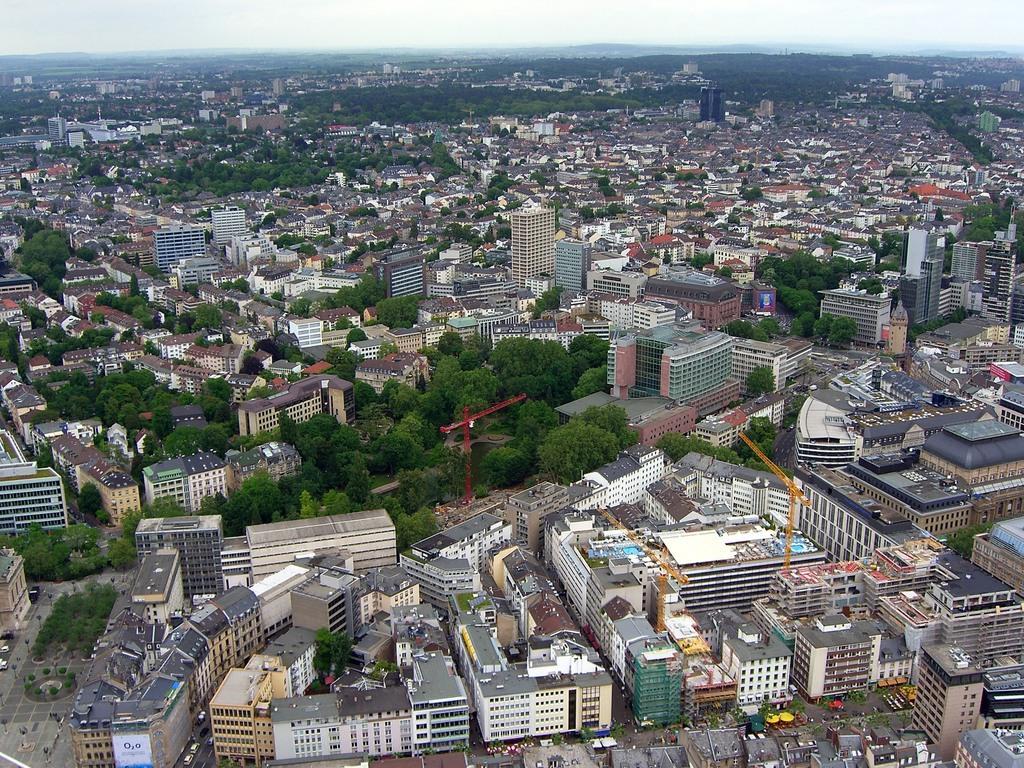Could you give a brief overview of what you see in this image? This is an aerial view and here we can see buildings, trees, poles, vehicles on the roads and there are towers. 